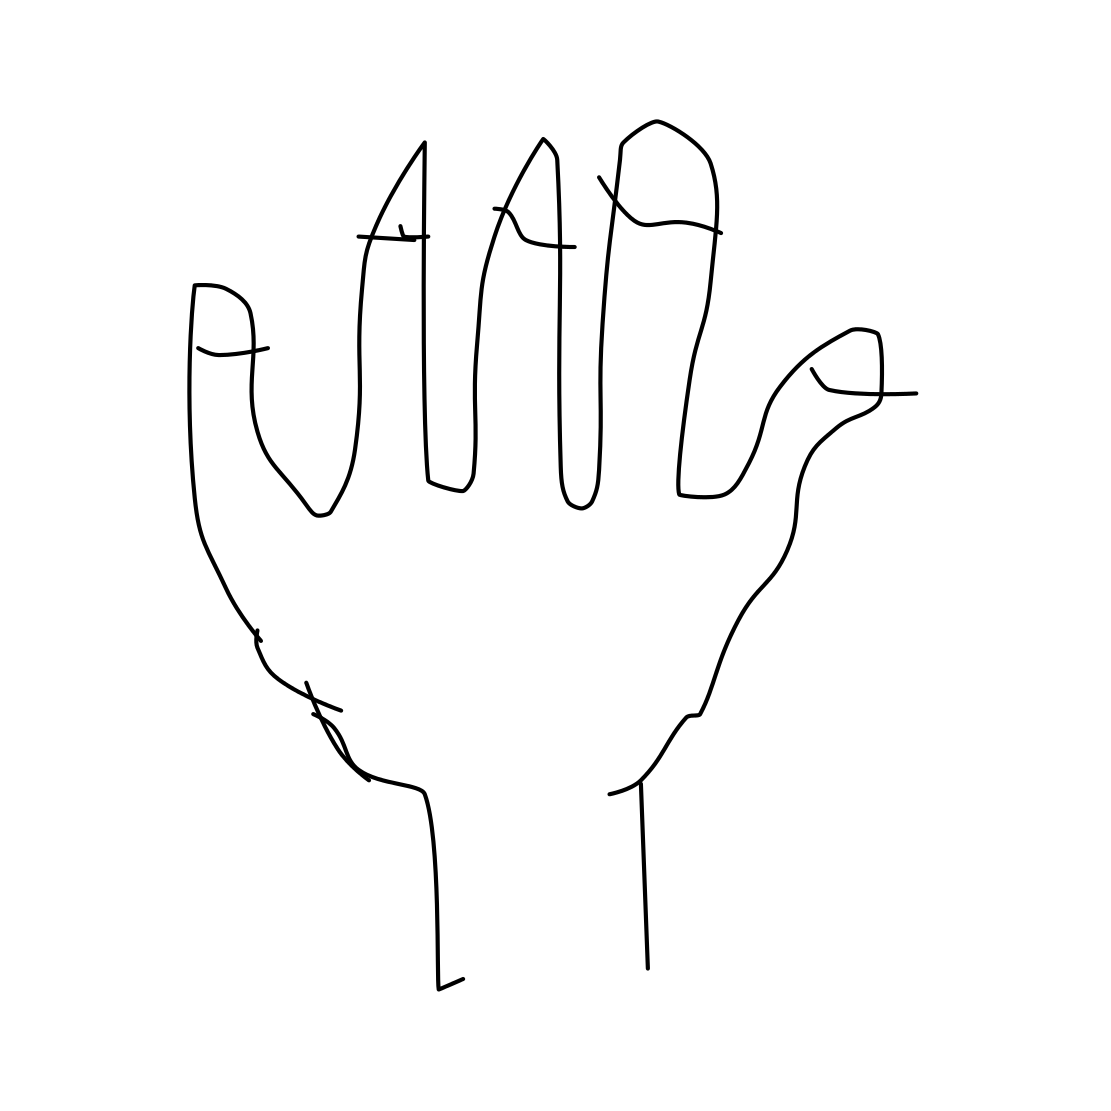Is this a hand in the image? Yes, the image shows a simple line drawing of a human hand. The fingers are extended upward, and although the drawing is quite minimalistic and lacks detail, the overall shape and number of fingers clearly suggest it's meant to represent a hand. 